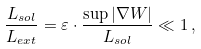Convert formula to latex. <formula><loc_0><loc_0><loc_500><loc_500>\frac { L _ { s o l } } { L _ { e x t } } = \varepsilon \cdot \frac { \sup | \nabla W | } { L _ { s o l } } \ll 1 \, ,</formula> 